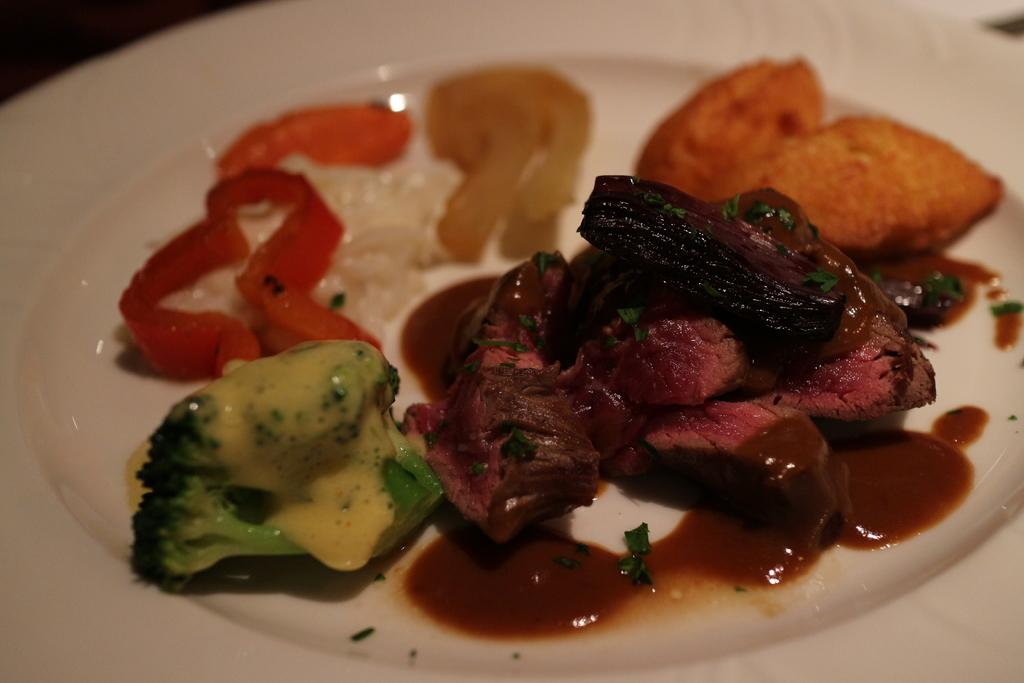What is the main object in the image? There is a white color palette in the image. What is on the palette? The palette contains sliced broccoli and other food items. What hobbies are being practiced in the image? There is no indication of any hobbies being practiced in the image; it only shows a color palette with food items. What type of board is visible in the image? There is no board present in the image. 